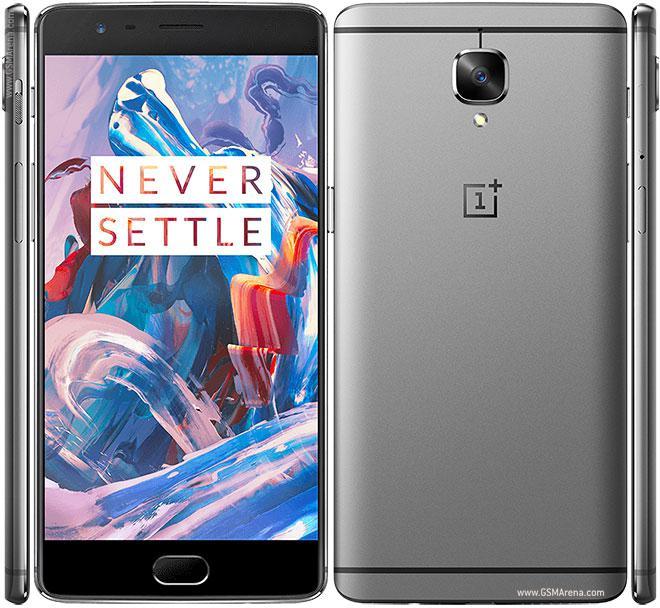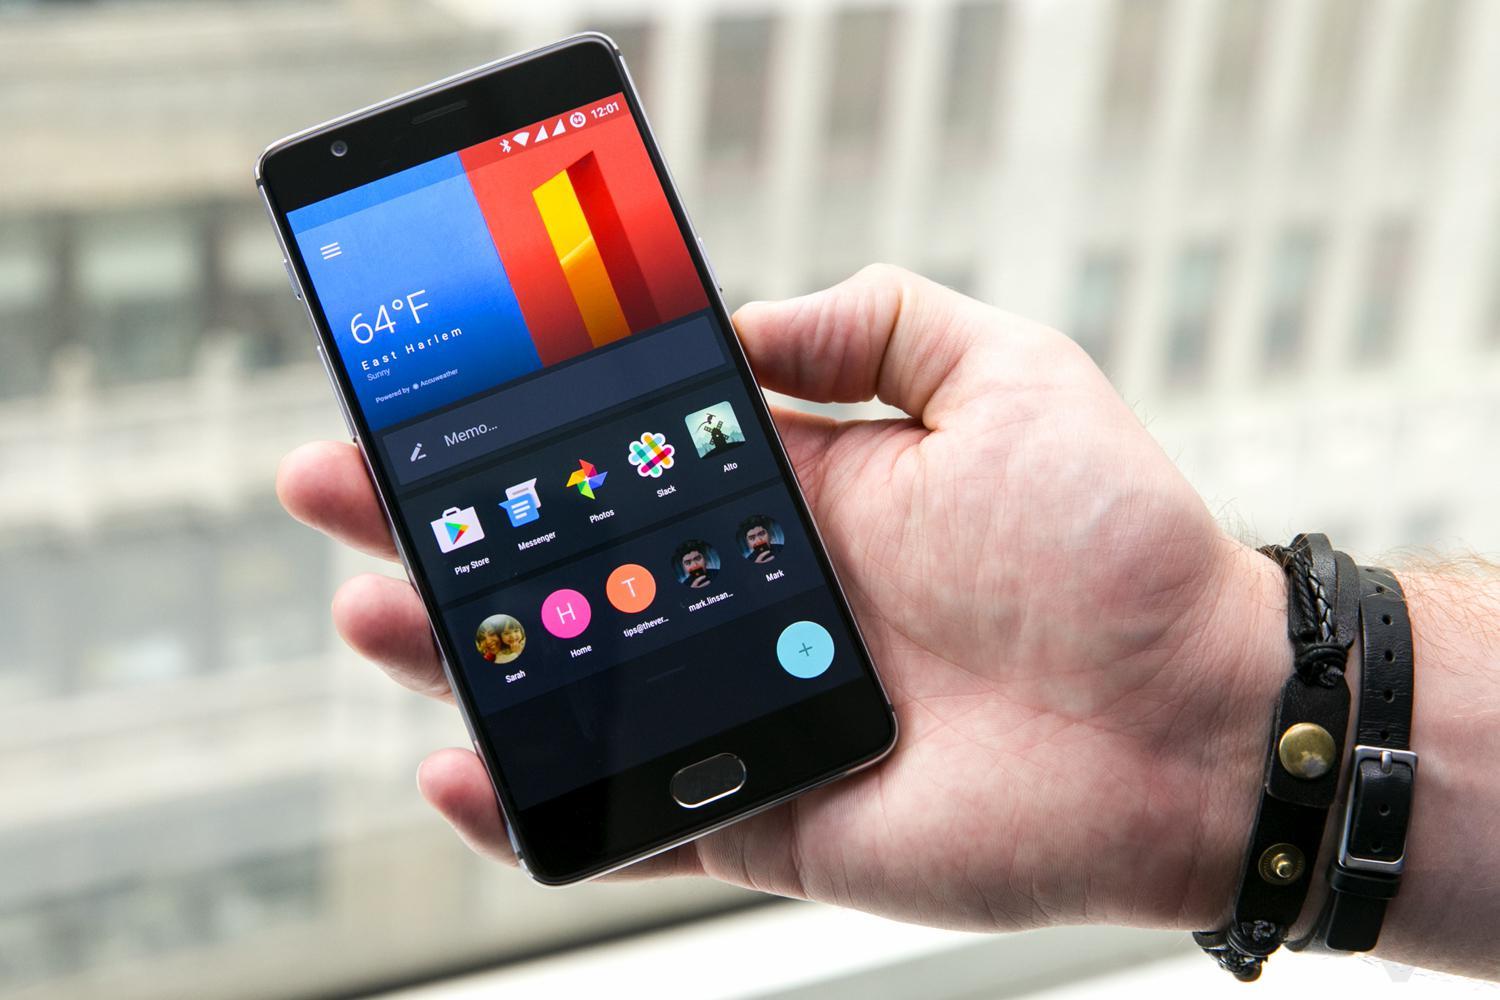The first image is the image on the left, the second image is the image on the right. Analyze the images presented: Is the assertion "The right image shows a hand holding a rectangular screen-front device angled to the left." valid? Answer yes or no. Yes. The first image is the image on the left, the second image is the image on the right. Examine the images to the left and right. Is the description "A person is holding the phone in the image on the right." accurate? Answer yes or no. Yes. 